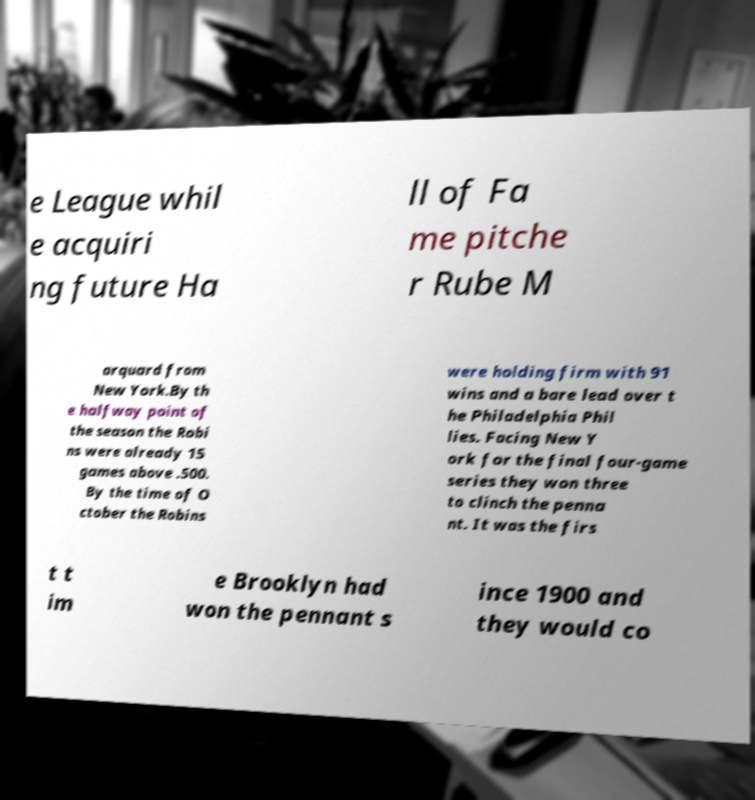For documentation purposes, I need the text within this image transcribed. Could you provide that? e League whil e acquiri ng future Ha ll of Fa me pitche r Rube M arquard from New York.By th e halfway point of the season the Robi ns were already 15 games above .500. By the time of O ctober the Robins were holding firm with 91 wins and a bare lead over t he Philadelphia Phil lies. Facing New Y ork for the final four-game series they won three to clinch the penna nt. It was the firs t t im e Brooklyn had won the pennant s ince 1900 and they would co 